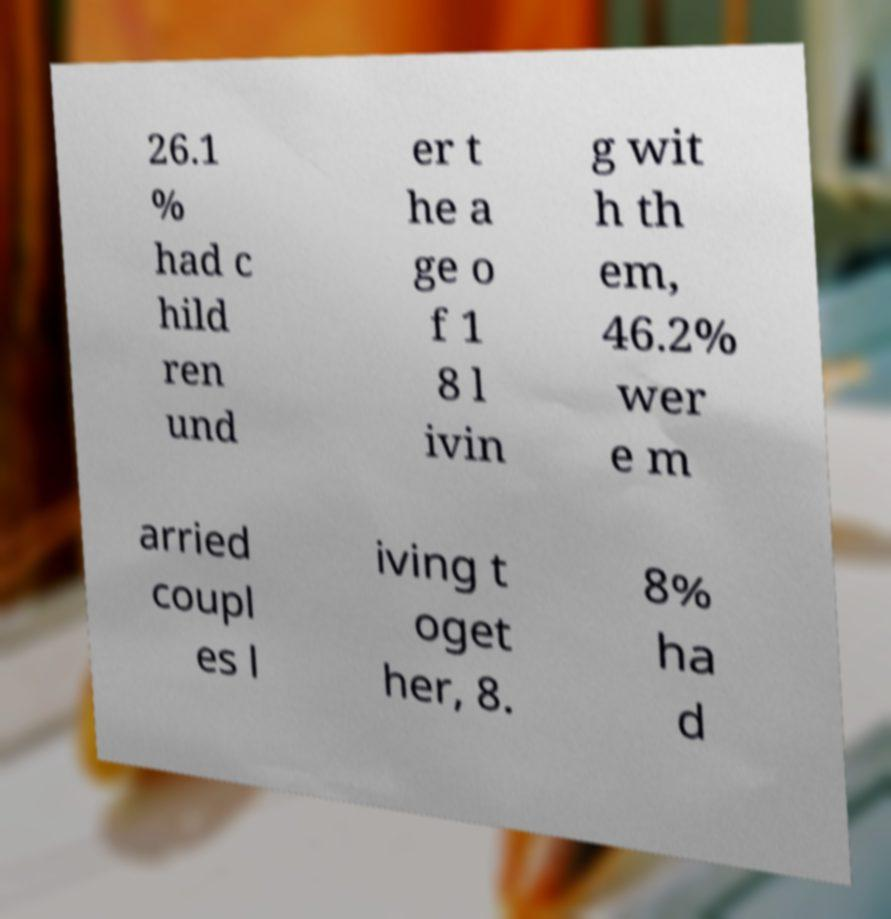For documentation purposes, I need the text within this image transcribed. Could you provide that? 26.1 % had c hild ren und er t he a ge o f 1 8 l ivin g wit h th em, 46.2% wer e m arried coupl es l iving t oget her, 8. 8% ha d 